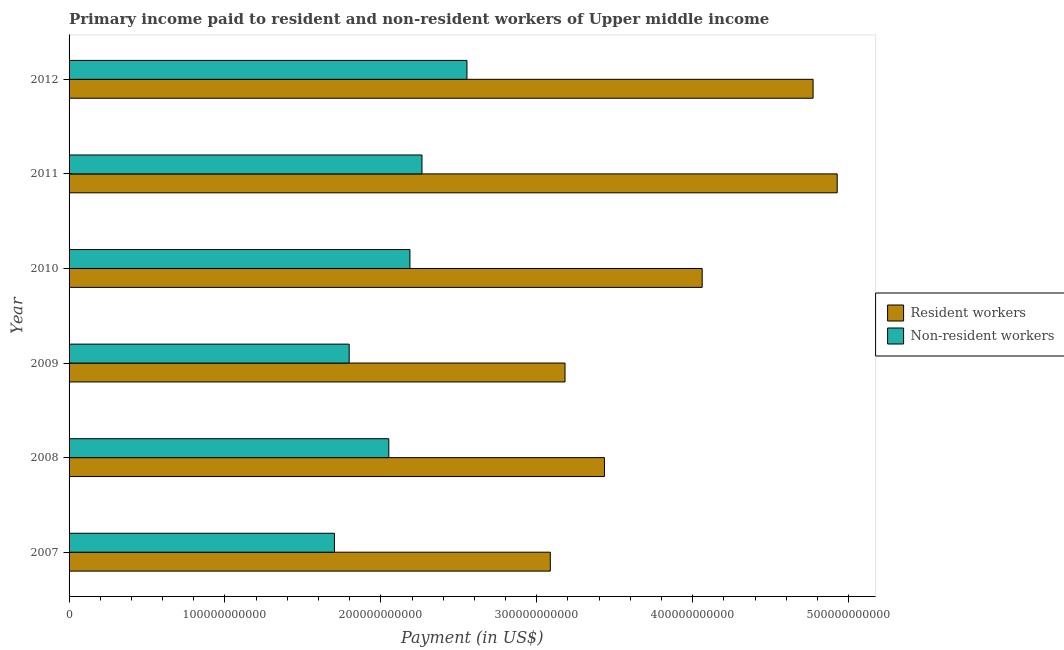How many groups of bars are there?
Offer a very short reply. 6. How many bars are there on the 1st tick from the top?
Offer a very short reply. 2. What is the label of the 2nd group of bars from the top?
Offer a terse response. 2011. In how many cases, is the number of bars for a given year not equal to the number of legend labels?
Your answer should be very brief. 0. What is the payment made to resident workers in 2012?
Ensure brevity in your answer.  4.77e+11. Across all years, what is the maximum payment made to non-resident workers?
Provide a short and direct response. 2.55e+11. Across all years, what is the minimum payment made to resident workers?
Your answer should be compact. 3.09e+11. In which year was the payment made to non-resident workers minimum?
Offer a terse response. 2007. What is the total payment made to non-resident workers in the graph?
Offer a very short reply. 1.26e+12. What is the difference between the payment made to non-resident workers in 2008 and that in 2009?
Keep it short and to the point. 2.54e+1. What is the difference between the payment made to non-resident workers in 2008 and the payment made to resident workers in 2007?
Provide a short and direct response. -1.04e+11. What is the average payment made to resident workers per year?
Provide a short and direct response. 3.91e+11. In the year 2010, what is the difference between the payment made to non-resident workers and payment made to resident workers?
Your answer should be compact. -1.87e+11. What is the ratio of the payment made to resident workers in 2007 to that in 2011?
Give a very brief answer. 0.63. Is the payment made to non-resident workers in 2008 less than that in 2010?
Your answer should be very brief. Yes. Is the difference between the payment made to non-resident workers in 2009 and 2012 greater than the difference between the payment made to resident workers in 2009 and 2012?
Keep it short and to the point. Yes. What is the difference between the highest and the second highest payment made to resident workers?
Offer a very short reply. 1.54e+1. What is the difference between the highest and the lowest payment made to non-resident workers?
Provide a short and direct response. 8.50e+1. In how many years, is the payment made to resident workers greater than the average payment made to resident workers taken over all years?
Give a very brief answer. 3. Is the sum of the payment made to resident workers in 2010 and 2012 greater than the maximum payment made to non-resident workers across all years?
Ensure brevity in your answer.  Yes. What does the 1st bar from the top in 2010 represents?
Your answer should be very brief. Non-resident workers. What does the 2nd bar from the bottom in 2007 represents?
Provide a short and direct response. Non-resident workers. Are all the bars in the graph horizontal?
Your response must be concise. Yes. How many years are there in the graph?
Provide a succinct answer. 6. What is the difference between two consecutive major ticks on the X-axis?
Ensure brevity in your answer.  1.00e+11. Does the graph contain grids?
Provide a short and direct response. No. How many legend labels are there?
Provide a succinct answer. 2. How are the legend labels stacked?
Ensure brevity in your answer.  Vertical. What is the title of the graph?
Ensure brevity in your answer.  Primary income paid to resident and non-resident workers of Upper middle income. Does "Agricultural land" appear as one of the legend labels in the graph?
Your response must be concise. No. What is the label or title of the X-axis?
Ensure brevity in your answer.  Payment (in US$). What is the Payment (in US$) in Resident workers in 2007?
Your answer should be compact. 3.09e+11. What is the Payment (in US$) of Non-resident workers in 2007?
Keep it short and to the point. 1.70e+11. What is the Payment (in US$) of Resident workers in 2008?
Ensure brevity in your answer.  3.43e+11. What is the Payment (in US$) in Non-resident workers in 2008?
Make the answer very short. 2.05e+11. What is the Payment (in US$) of Resident workers in 2009?
Give a very brief answer. 3.18e+11. What is the Payment (in US$) of Non-resident workers in 2009?
Your response must be concise. 1.80e+11. What is the Payment (in US$) of Resident workers in 2010?
Your answer should be compact. 4.06e+11. What is the Payment (in US$) of Non-resident workers in 2010?
Offer a terse response. 2.19e+11. What is the Payment (in US$) of Resident workers in 2011?
Your answer should be compact. 4.93e+11. What is the Payment (in US$) of Non-resident workers in 2011?
Ensure brevity in your answer.  2.26e+11. What is the Payment (in US$) in Resident workers in 2012?
Provide a short and direct response. 4.77e+11. What is the Payment (in US$) in Non-resident workers in 2012?
Give a very brief answer. 2.55e+11. Across all years, what is the maximum Payment (in US$) of Resident workers?
Provide a succinct answer. 4.93e+11. Across all years, what is the maximum Payment (in US$) of Non-resident workers?
Your answer should be very brief. 2.55e+11. Across all years, what is the minimum Payment (in US$) in Resident workers?
Provide a short and direct response. 3.09e+11. Across all years, what is the minimum Payment (in US$) of Non-resident workers?
Keep it short and to the point. 1.70e+11. What is the total Payment (in US$) in Resident workers in the graph?
Ensure brevity in your answer.  2.35e+12. What is the total Payment (in US$) of Non-resident workers in the graph?
Offer a very short reply. 1.26e+12. What is the difference between the Payment (in US$) of Resident workers in 2007 and that in 2008?
Give a very brief answer. -3.47e+1. What is the difference between the Payment (in US$) of Non-resident workers in 2007 and that in 2008?
Your answer should be compact. -3.49e+1. What is the difference between the Payment (in US$) of Resident workers in 2007 and that in 2009?
Your answer should be very brief. -9.44e+09. What is the difference between the Payment (in US$) of Non-resident workers in 2007 and that in 2009?
Make the answer very short. -9.45e+09. What is the difference between the Payment (in US$) in Resident workers in 2007 and that in 2010?
Your answer should be very brief. -9.74e+1. What is the difference between the Payment (in US$) in Non-resident workers in 2007 and that in 2010?
Keep it short and to the point. -4.84e+1. What is the difference between the Payment (in US$) of Resident workers in 2007 and that in 2011?
Provide a succinct answer. -1.84e+11. What is the difference between the Payment (in US$) of Non-resident workers in 2007 and that in 2011?
Give a very brief answer. -5.61e+1. What is the difference between the Payment (in US$) of Resident workers in 2007 and that in 2012?
Provide a short and direct response. -1.69e+11. What is the difference between the Payment (in US$) in Non-resident workers in 2007 and that in 2012?
Provide a short and direct response. -8.50e+1. What is the difference between the Payment (in US$) of Resident workers in 2008 and that in 2009?
Ensure brevity in your answer.  2.53e+1. What is the difference between the Payment (in US$) of Non-resident workers in 2008 and that in 2009?
Ensure brevity in your answer.  2.54e+1. What is the difference between the Payment (in US$) in Resident workers in 2008 and that in 2010?
Make the answer very short. -6.27e+1. What is the difference between the Payment (in US$) in Non-resident workers in 2008 and that in 2010?
Ensure brevity in your answer.  -1.36e+1. What is the difference between the Payment (in US$) in Resident workers in 2008 and that in 2011?
Provide a short and direct response. -1.49e+11. What is the difference between the Payment (in US$) of Non-resident workers in 2008 and that in 2011?
Keep it short and to the point. -2.13e+1. What is the difference between the Payment (in US$) of Resident workers in 2008 and that in 2012?
Offer a very short reply. -1.34e+11. What is the difference between the Payment (in US$) in Non-resident workers in 2008 and that in 2012?
Offer a very short reply. -5.01e+1. What is the difference between the Payment (in US$) in Resident workers in 2009 and that in 2010?
Ensure brevity in your answer.  -8.80e+1. What is the difference between the Payment (in US$) in Non-resident workers in 2009 and that in 2010?
Keep it short and to the point. -3.90e+1. What is the difference between the Payment (in US$) of Resident workers in 2009 and that in 2011?
Offer a very short reply. -1.75e+11. What is the difference between the Payment (in US$) in Non-resident workers in 2009 and that in 2011?
Your answer should be very brief. -4.67e+1. What is the difference between the Payment (in US$) of Resident workers in 2009 and that in 2012?
Ensure brevity in your answer.  -1.59e+11. What is the difference between the Payment (in US$) in Non-resident workers in 2009 and that in 2012?
Keep it short and to the point. -7.55e+1. What is the difference between the Payment (in US$) in Resident workers in 2010 and that in 2011?
Give a very brief answer. -8.66e+1. What is the difference between the Payment (in US$) in Non-resident workers in 2010 and that in 2011?
Offer a terse response. -7.73e+09. What is the difference between the Payment (in US$) of Resident workers in 2010 and that in 2012?
Your answer should be very brief. -7.11e+1. What is the difference between the Payment (in US$) in Non-resident workers in 2010 and that in 2012?
Give a very brief answer. -3.66e+1. What is the difference between the Payment (in US$) of Resident workers in 2011 and that in 2012?
Give a very brief answer. 1.54e+1. What is the difference between the Payment (in US$) of Non-resident workers in 2011 and that in 2012?
Provide a succinct answer. -2.88e+1. What is the difference between the Payment (in US$) of Resident workers in 2007 and the Payment (in US$) of Non-resident workers in 2008?
Your answer should be very brief. 1.04e+11. What is the difference between the Payment (in US$) in Resident workers in 2007 and the Payment (in US$) in Non-resident workers in 2009?
Provide a short and direct response. 1.29e+11. What is the difference between the Payment (in US$) of Resident workers in 2007 and the Payment (in US$) of Non-resident workers in 2010?
Offer a very short reply. 9.00e+1. What is the difference between the Payment (in US$) of Resident workers in 2007 and the Payment (in US$) of Non-resident workers in 2011?
Give a very brief answer. 8.23e+1. What is the difference between the Payment (in US$) of Resident workers in 2007 and the Payment (in US$) of Non-resident workers in 2012?
Make the answer very short. 5.35e+1. What is the difference between the Payment (in US$) of Resident workers in 2008 and the Payment (in US$) of Non-resident workers in 2009?
Your answer should be compact. 1.64e+11. What is the difference between the Payment (in US$) in Resident workers in 2008 and the Payment (in US$) in Non-resident workers in 2010?
Your answer should be very brief. 1.25e+11. What is the difference between the Payment (in US$) in Resident workers in 2008 and the Payment (in US$) in Non-resident workers in 2011?
Make the answer very short. 1.17e+11. What is the difference between the Payment (in US$) of Resident workers in 2008 and the Payment (in US$) of Non-resident workers in 2012?
Make the answer very short. 8.82e+1. What is the difference between the Payment (in US$) of Resident workers in 2009 and the Payment (in US$) of Non-resident workers in 2010?
Your answer should be compact. 9.95e+1. What is the difference between the Payment (in US$) of Resident workers in 2009 and the Payment (in US$) of Non-resident workers in 2011?
Ensure brevity in your answer.  9.17e+1. What is the difference between the Payment (in US$) in Resident workers in 2009 and the Payment (in US$) in Non-resident workers in 2012?
Provide a succinct answer. 6.29e+1. What is the difference between the Payment (in US$) of Resident workers in 2010 and the Payment (in US$) of Non-resident workers in 2011?
Your response must be concise. 1.80e+11. What is the difference between the Payment (in US$) of Resident workers in 2010 and the Payment (in US$) of Non-resident workers in 2012?
Give a very brief answer. 1.51e+11. What is the difference between the Payment (in US$) of Resident workers in 2011 and the Payment (in US$) of Non-resident workers in 2012?
Provide a succinct answer. 2.37e+11. What is the average Payment (in US$) of Resident workers per year?
Ensure brevity in your answer.  3.91e+11. What is the average Payment (in US$) of Non-resident workers per year?
Give a very brief answer. 2.09e+11. In the year 2007, what is the difference between the Payment (in US$) in Resident workers and Payment (in US$) in Non-resident workers?
Provide a succinct answer. 1.38e+11. In the year 2008, what is the difference between the Payment (in US$) in Resident workers and Payment (in US$) in Non-resident workers?
Provide a short and direct response. 1.38e+11. In the year 2009, what is the difference between the Payment (in US$) of Resident workers and Payment (in US$) of Non-resident workers?
Offer a terse response. 1.38e+11. In the year 2010, what is the difference between the Payment (in US$) of Resident workers and Payment (in US$) of Non-resident workers?
Provide a short and direct response. 1.87e+11. In the year 2011, what is the difference between the Payment (in US$) of Resident workers and Payment (in US$) of Non-resident workers?
Offer a very short reply. 2.66e+11. In the year 2012, what is the difference between the Payment (in US$) in Resident workers and Payment (in US$) in Non-resident workers?
Your response must be concise. 2.22e+11. What is the ratio of the Payment (in US$) of Resident workers in 2007 to that in 2008?
Provide a succinct answer. 0.9. What is the ratio of the Payment (in US$) of Non-resident workers in 2007 to that in 2008?
Provide a succinct answer. 0.83. What is the ratio of the Payment (in US$) in Resident workers in 2007 to that in 2009?
Ensure brevity in your answer.  0.97. What is the ratio of the Payment (in US$) in Non-resident workers in 2007 to that in 2009?
Provide a succinct answer. 0.95. What is the ratio of the Payment (in US$) in Resident workers in 2007 to that in 2010?
Make the answer very short. 0.76. What is the ratio of the Payment (in US$) in Non-resident workers in 2007 to that in 2010?
Provide a short and direct response. 0.78. What is the ratio of the Payment (in US$) in Resident workers in 2007 to that in 2011?
Make the answer very short. 0.63. What is the ratio of the Payment (in US$) of Non-resident workers in 2007 to that in 2011?
Offer a terse response. 0.75. What is the ratio of the Payment (in US$) in Resident workers in 2007 to that in 2012?
Your answer should be compact. 0.65. What is the ratio of the Payment (in US$) in Non-resident workers in 2007 to that in 2012?
Make the answer very short. 0.67. What is the ratio of the Payment (in US$) in Resident workers in 2008 to that in 2009?
Provide a short and direct response. 1.08. What is the ratio of the Payment (in US$) of Non-resident workers in 2008 to that in 2009?
Offer a terse response. 1.14. What is the ratio of the Payment (in US$) in Resident workers in 2008 to that in 2010?
Your answer should be very brief. 0.85. What is the ratio of the Payment (in US$) of Non-resident workers in 2008 to that in 2010?
Give a very brief answer. 0.94. What is the ratio of the Payment (in US$) in Resident workers in 2008 to that in 2011?
Provide a short and direct response. 0.7. What is the ratio of the Payment (in US$) in Non-resident workers in 2008 to that in 2011?
Offer a terse response. 0.91. What is the ratio of the Payment (in US$) in Resident workers in 2008 to that in 2012?
Provide a succinct answer. 0.72. What is the ratio of the Payment (in US$) of Non-resident workers in 2008 to that in 2012?
Offer a terse response. 0.8. What is the ratio of the Payment (in US$) in Resident workers in 2009 to that in 2010?
Provide a short and direct response. 0.78. What is the ratio of the Payment (in US$) in Non-resident workers in 2009 to that in 2010?
Provide a short and direct response. 0.82. What is the ratio of the Payment (in US$) of Resident workers in 2009 to that in 2011?
Provide a succinct answer. 0.65. What is the ratio of the Payment (in US$) in Non-resident workers in 2009 to that in 2011?
Ensure brevity in your answer.  0.79. What is the ratio of the Payment (in US$) of Resident workers in 2009 to that in 2012?
Keep it short and to the point. 0.67. What is the ratio of the Payment (in US$) of Non-resident workers in 2009 to that in 2012?
Keep it short and to the point. 0.7. What is the ratio of the Payment (in US$) in Resident workers in 2010 to that in 2011?
Keep it short and to the point. 0.82. What is the ratio of the Payment (in US$) of Non-resident workers in 2010 to that in 2011?
Provide a succinct answer. 0.97. What is the ratio of the Payment (in US$) in Resident workers in 2010 to that in 2012?
Your response must be concise. 0.85. What is the ratio of the Payment (in US$) of Non-resident workers in 2010 to that in 2012?
Provide a short and direct response. 0.86. What is the ratio of the Payment (in US$) in Resident workers in 2011 to that in 2012?
Provide a succinct answer. 1.03. What is the ratio of the Payment (in US$) in Non-resident workers in 2011 to that in 2012?
Ensure brevity in your answer.  0.89. What is the difference between the highest and the second highest Payment (in US$) of Resident workers?
Keep it short and to the point. 1.54e+1. What is the difference between the highest and the second highest Payment (in US$) in Non-resident workers?
Provide a short and direct response. 2.88e+1. What is the difference between the highest and the lowest Payment (in US$) of Resident workers?
Your response must be concise. 1.84e+11. What is the difference between the highest and the lowest Payment (in US$) in Non-resident workers?
Offer a very short reply. 8.50e+1. 